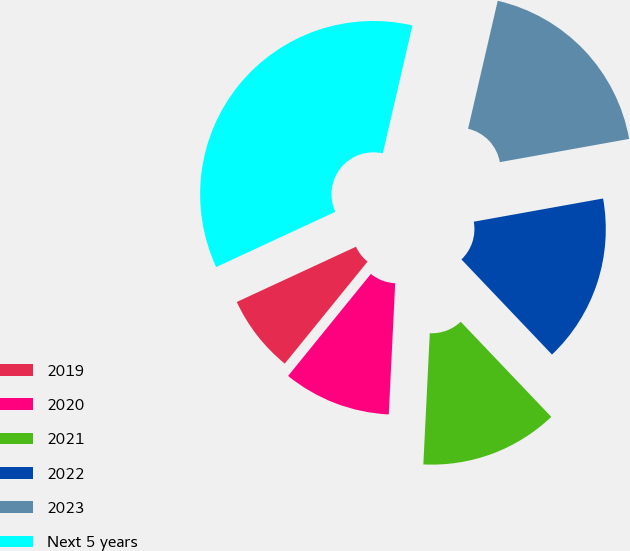<chart> <loc_0><loc_0><loc_500><loc_500><pie_chart><fcel>2019<fcel>2020<fcel>2021<fcel>2022<fcel>2023<fcel>Next 5 years<nl><fcel>7.24%<fcel>10.07%<fcel>12.89%<fcel>15.72%<fcel>18.55%<fcel>35.53%<nl></chart> 